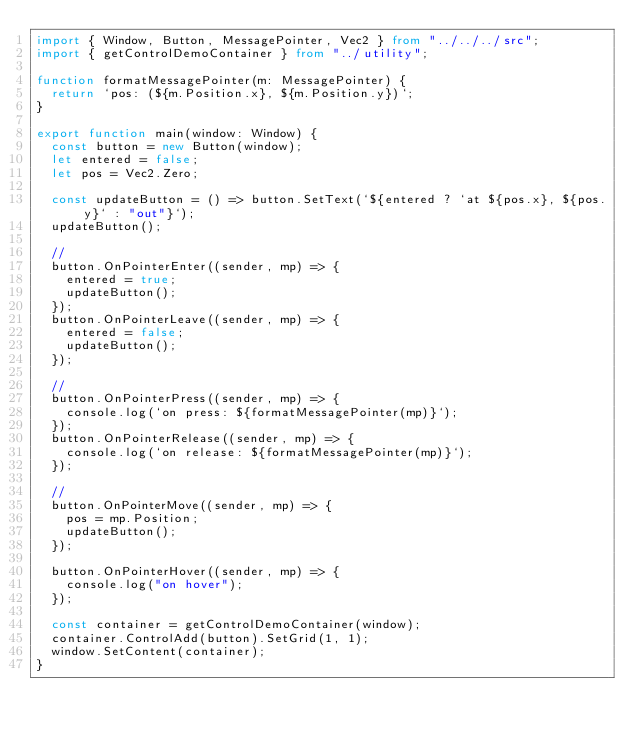<code> <loc_0><loc_0><loc_500><loc_500><_TypeScript_>import { Window, Button, MessagePointer, Vec2 } from "../../../src";
import { getControlDemoContainer } from "../utility";

function formatMessagePointer(m: MessagePointer) {
	return `pos: (${m.Position.x}, ${m.Position.y})`;
}

export function main(window: Window) {
	const button = new Button(window);
	let entered = false;
	let pos = Vec2.Zero;

	const updateButton = () => button.SetText(`${entered ? `at ${pos.x}, ${pos.y}` : "out"}`);
	updateButton();

	//
	button.OnPointerEnter((sender, mp) => {
		entered = true;
		updateButton();
	});
	button.OnPointerLeave((sender, mp) => {
		entered = false;
		updateButton();
	});

	//
	button.OnPointerPress((sender, mp) => {
		console.log(`on press: ${formatMessagePointer(mp)}`);
	});
	button.OnPointerRelease((sender, mp) => {
		console.log(`on release: ${formatMessagePointer(mp)}`);
	});

	//
	button.OnPointerMove((sender, mp) => {
		pos = mp.Position;
		updateButton();
	});

	button.OnPointerHover((sender, mp) => {
		console.log("on hover");
	});

	const container = getControlDemoContainer(window);
	container.ControlAdd(button).SetGrid(1, 1);
	window.SetContent(container);
}
</code> 